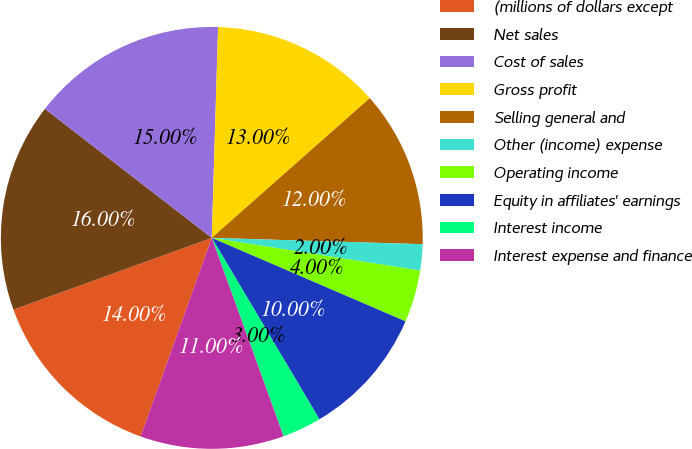Convert chart. <chart><loc_0><loc_0><loc_500><loc_500><pie_chart><fcel>(millions of dollars except<fcel>Net sales<fcel>Cost of sales<fcel>Gross profit<fcel>Selling general and<fcel>Other (income) expense<fcel>Operating income<fcel>Equity in affiliates' earnings<fcel>Interest income<fcel>Interest expense and finance<nl><fcel>14.0%<fcel>16.0%<fcel>15.0%<fcel>13.0%<fcel>12.0%<fcel>2.0%<fcel>4.0%<fcel>10.0%<fcel>3.0%<fcel>11.0%<nl></chart> 